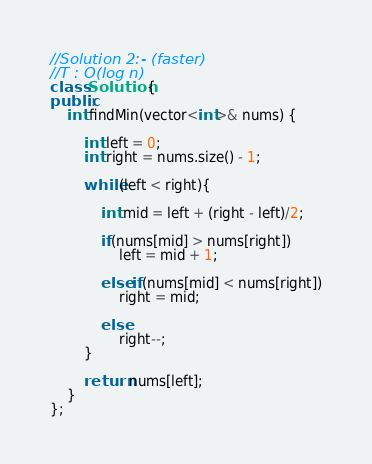<code> <loc_0><loc_0><loc_500><loc_500><_C++_>//Solution 2:- (faster)
//T : O(log n)
class Solution {
public:
    int findMin(vector<int>& nums) {
        
        int left = 0;
        int right = nums.size() - 1;
        
        while(left < right){
            
            int mid = left + (right - left)/2;
            
            if(nums[mid] > nums[right])
                left = mid + 1;
            
            else if(nums[mid] < nums[right])
                right = mid;
            
            else
                right--;
        }
        
        return nums[left];
    }
};
</code> 